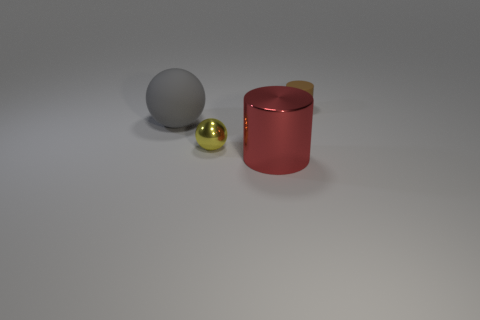Is the number of tiny objects in front of the small matte cylinder greater than the number of large gray cubes?
Keep it short and to the point. Yes. What is the material of the small object right of the big shiny cylinder?
Your response must be concise. Rubber. What is the color of the small metallic object that is the same shape as the large gray object?
Keep it short and to the point. Yellow. What number of big rubber spheres have the same color as the metallic cylinder?
Your answer should be very brief. 0. Is the size of the sphere right of the big sphere the same as the cylinder behind the big gray sphere?
Offer a terse response. Yes. There is a red cylinder; does it have the same size as the matte thing that is left of the small brown cylinder?
Make the answer very short. Yes. What is the size of the gray matte object?
Provide a short and direct response. Large. There is a sphere that is made of the same material as the large red cylinder; what color is it?
Provide a succinct answer. Yellow. What number of yellow things have the same material as the brown object?
Give a very brief answer. 0. What number of things are tiny rubber cylinders or tiny things to the right of the metal cylinder?
Give a very brief answer. 1. 